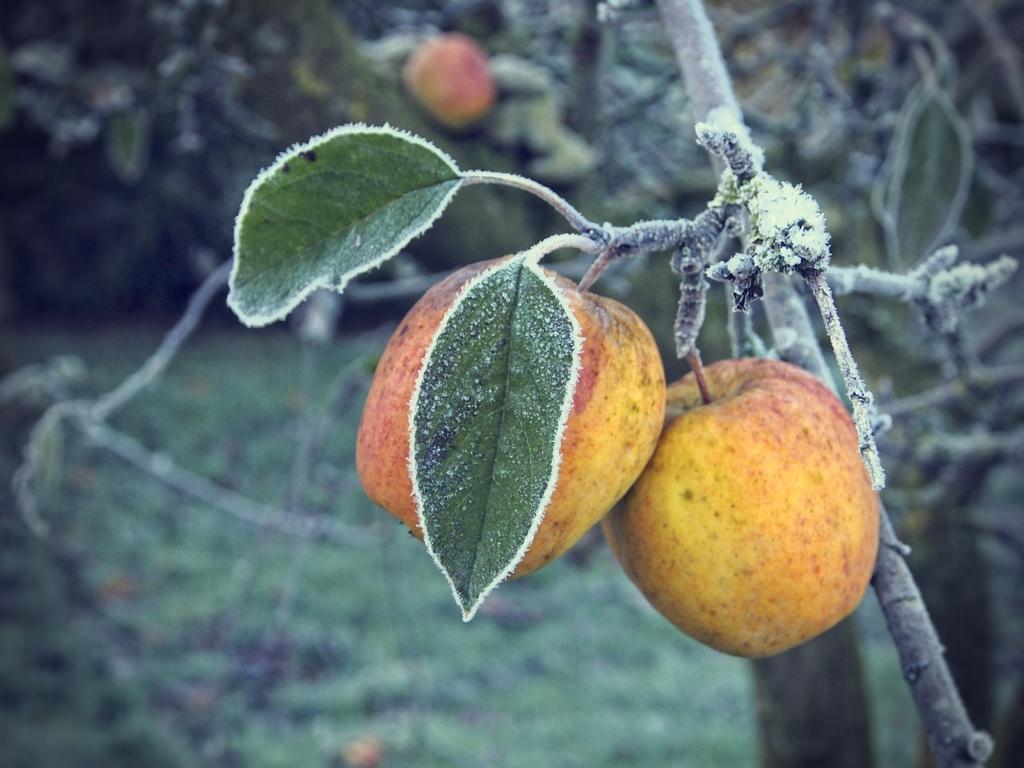What type of food can be seen in the image? There are fruits in the image. What part of a plant is emphasized in the image? The leaves of a tree are highlighted in the image. How would you describe the background of the image? The background of the image is blurred. What type of care can be seen being provided to the fruits in the image? There is no indication of care being provided to the fruits in the image; they are simply depicted as they are. 